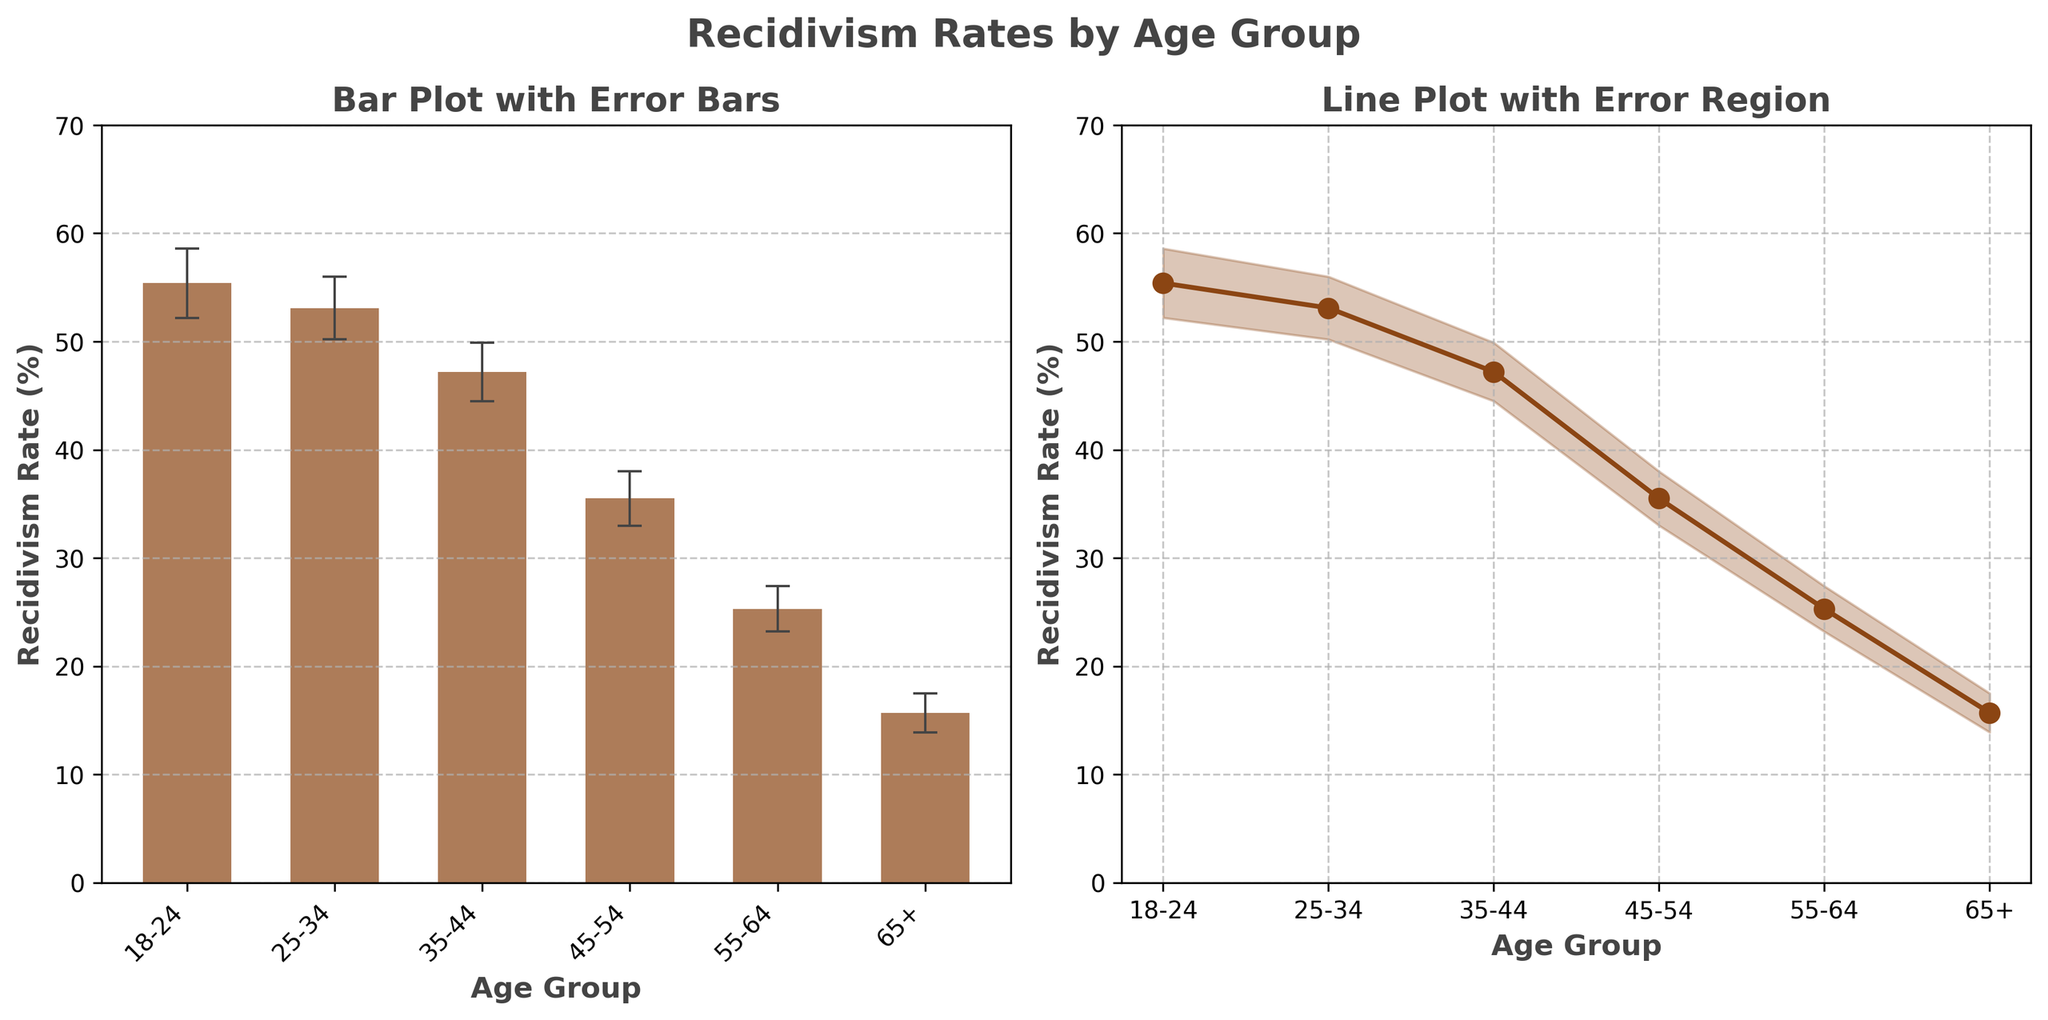What's the title of the figure? The title of the figure is prominently displayed at the top of the figure.
Answer: Recidivism Rates by Age Group What does the x-axis represent in both subplots? The x-axis labels are the same on both subplots and correspond to the age groups listed at the bottom of each subplot.
Answer: Age Group What is the recidivism rate for the 25-34 age group? The bar for the 25-34 age group reaches up to the corresponding recidivism rate value. Also, the same value is plotted as a point on the line plot.
Answer: 53.1% What is the difference in recidivism rate between the 18-24 and 65+ age groups? Subtract the recidivism rate of the 65+ age group from that of the 18-24 age group (55.4% - 15.7%).
Answer: 39.7% Which age group has the smallest error margin, and what is that margin? Look at the error margins bars and lines; the smallest should correspond to the age group with the smallest vertical range along the error margin.
Answer: 65+, 1.8% Is the recidivism rate trend increasing or decreasing as the age group increases? Observe the overall direction of the line plot and bars from the youngest age group (18-24) to the oldest (65+).
Answer: Decreasing Which age group has the highest recidivism rate, and what is that rate? Identify the tallest bar in the bar plot and the highest point on the line plot.
Answer: 18-24, 55.4% What is the recidivism rate for the age group 45-54, and what are its upper and lower error margins? Locate the bar or point corresponding to the 45-54 age group, and then note the error bars that add and subtract from this value. The lower limit is (35.5% - 2.5%) and the upper limit is (35.5% + 2.5%).
Answer: 35.5%, 33.0% and 38.0% How does the 25-34 age group's recidivism error margin compare to that of the 55-64 age group? Compare the length of the error bars or the size of the error-filled region for both age groups. The error margin for the 25-34 group is 2.9% and for the 55-64 group is 2.1%.
Answer: 25-34 has a larger error margin What's the average recidivism rate across all age groups? Add up all the recidivism rates (55.4 + 53.1 + 47.2 + 35.5 + 25.3 + 15.7) and divide by the number of age groups (6).
Answer: 38.7% 